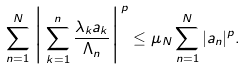Convert formula to latex. <formula><loc_0><loc_0><loc_500><loc_500>\sum ^ { N } _ { n = 1 } \Big { | } \sum ^ { n } _ { k = 1 } \frac { \lambda _ { k } a _ { k } } { \Lambda _ { n } } \Big { | } ^ { p } \leq \mu _ { N } \sum ^ { N } _ { n = 1 } | a _ { n } | ^ { p } .</formula> 